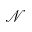<formula> <loc_0><loc_0><loc_500><loc_500>\mathcal { N }</formula> 